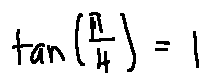<formula> <loc_0><loc_0><loc_500><loc_500>\tan ( \frac { \pi } { 4 } ) = 1</formula> 